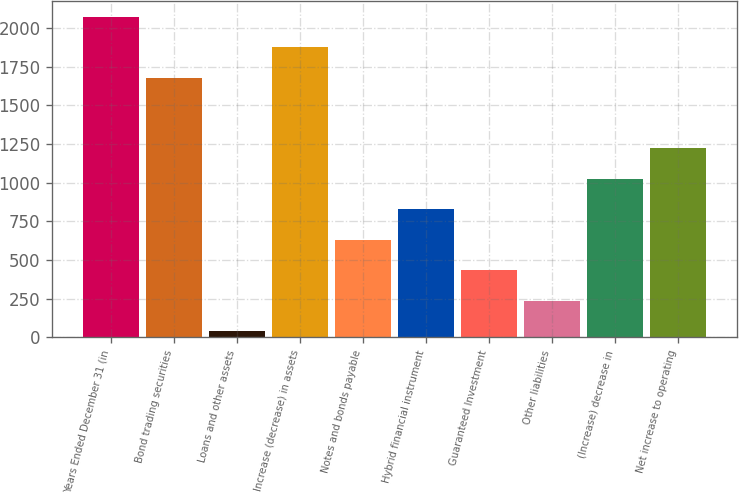Convert chart to OTSL. <chart><loc_0><loc_0><loc_500><loc_500><bar_chart><fcel>Years Ended December 31 (in<fcel>Bond trading securities<fcel>Loans and other assets<fcel>Increase (decrease) in assets<fcel>Notes and bonds payable<fcel>Hybrid financial instrument<fcel>Guaranteed Investment<fcel>Other liabilities<fcel>(Increase) decrease in<fcel>Net increase to operating<nl><fcel>2072<fcel>1678<fcel>40<fcel>1875<fcel>631<fcel>828<fcel>434<fcel>237<fcel>1025<fcel>1222<nl></chart> 